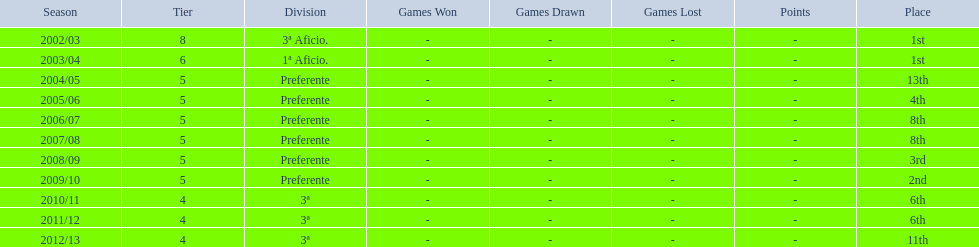Which segment positioned above aficio 1a and 3a? Preferente. 